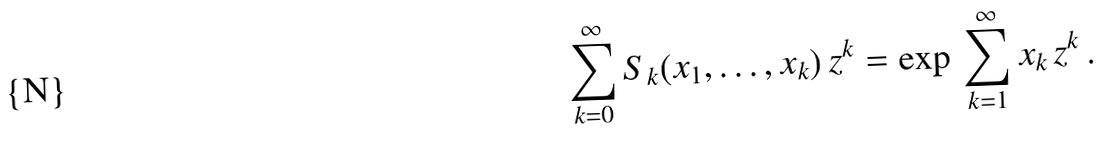Convert formula to latex. <formula><loc_0><loc_0><loc_500><loc_500>\sum _ { k = 0 } ^ { \infty } S _ { k } ( x _ { 1 } , \dots , x _ { k } ) \, z ^ { k } = \exp \, \sum _ { k = 1 } ^ { \infty } x _ { k } \, z ^ { k } \, .</formula> 